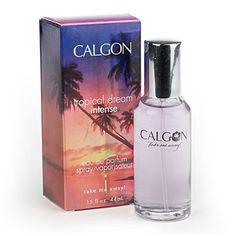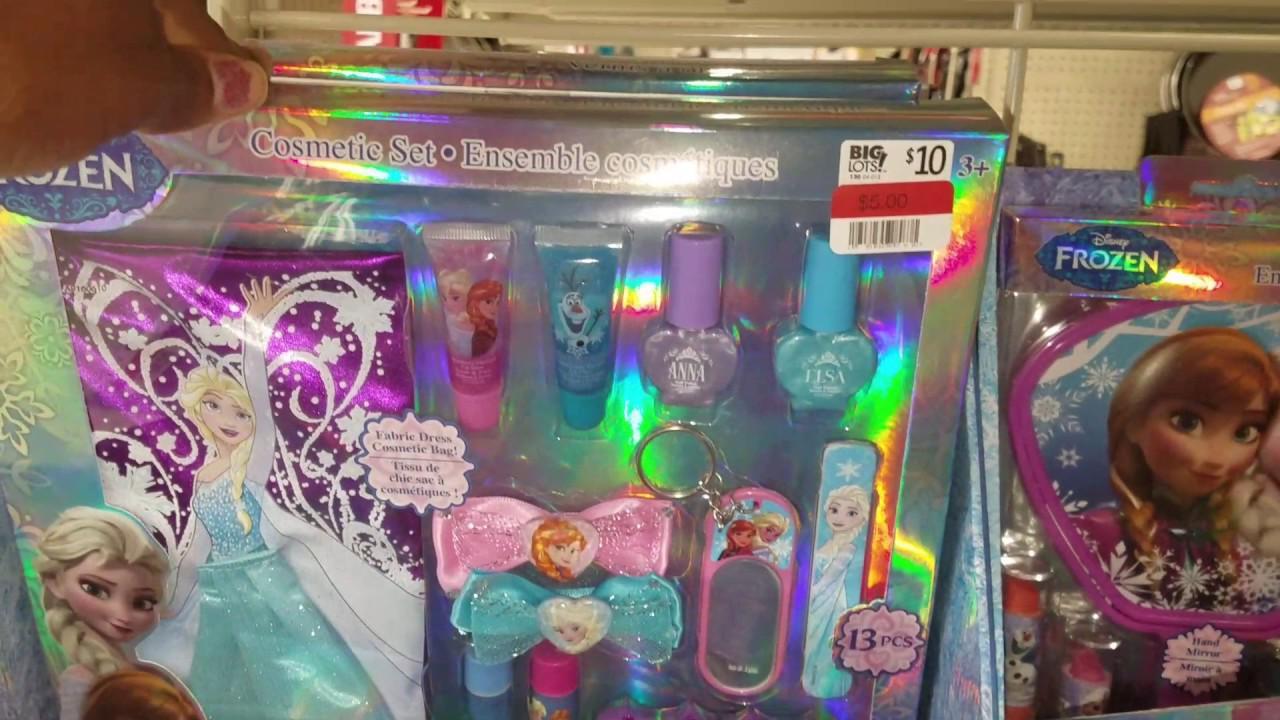The first image is the image on the left, the second image is the image on the right. Given the left and right images, does the statement "An image shows exactly one fragrance standing to the right of its box." hold true? Answer yes or no. Yes. The first image is the image on the left, the second image is the image on the right. Examine the images to the left and right. Is the description "There is exactly one perfume bottle in the right image." accurate? Answer yes or no. No. 